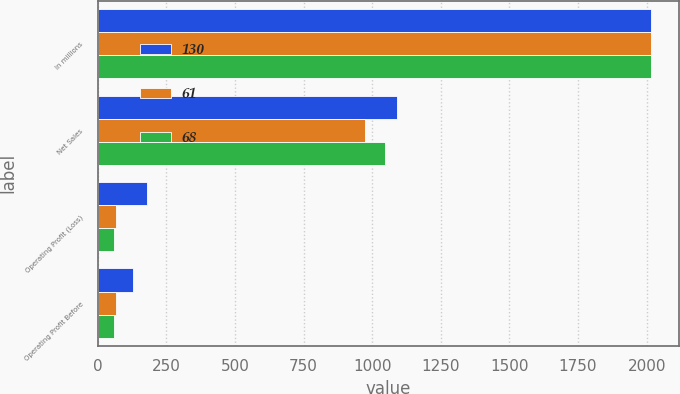Convert chart. <chart><loc_0><loc_0><loc_500><loc_500><stacked_bar_chart><ecel><fcel>In millions<fcel>Net Sales<fcel>Operating Profit (Loss)<fcel>Operating Profit Before<nl><fcel>130<fcel>2016<fcel>1092<fcel>180<fcel>130<nl><fcel>61<fcel>2015<fcel>975<fcel>68<fcel>68<nl><fcel>68<fcel>2014<fcel>1046<fcel>61<fcel>61<nl></chart> 